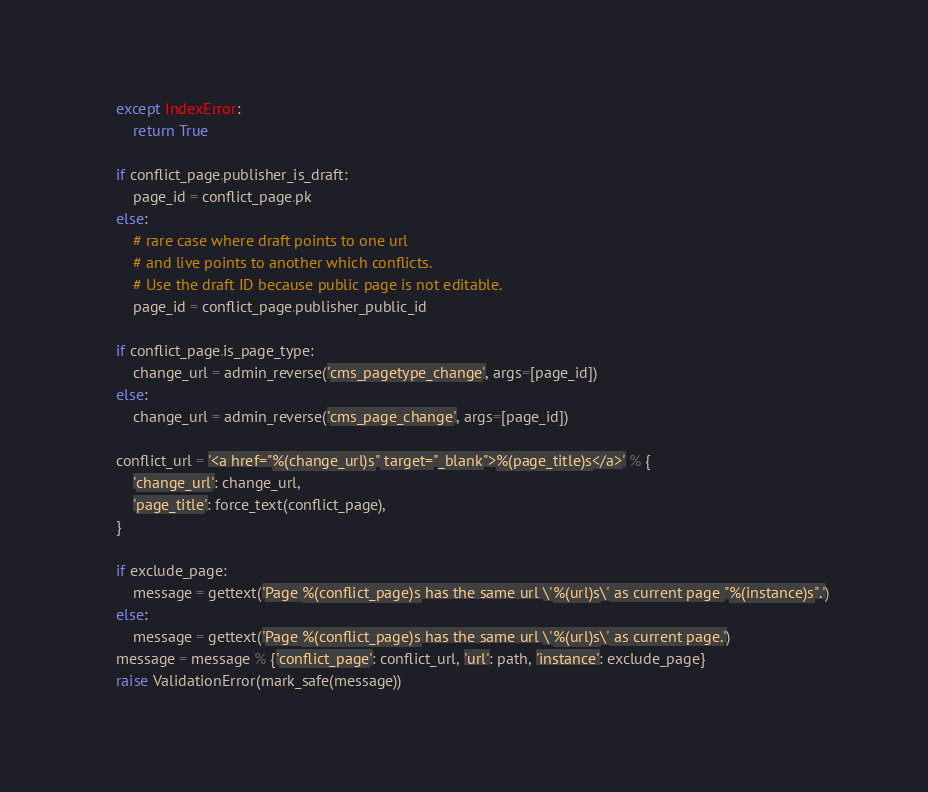<code> <loc_0><loc_0><loc_500><loc_500><_Python_>    except IndexError:
        return True

    if conflict_page.publisher_is_draft:
        page_id = conflict_page.pk
    else:
        # rare case where draft points to one url
        # and live points to another which conflicts.
        # Use the draft ID because public page is not editable.
        page_id = conflict_page.publisher_public_id

    if conflict_page.is_page_type:
        change_url = admin_reverse('cms_pagetype_change', args=[page_id])
    else:
        change_url = admin_reverse('cms_page_change', args=[page_id])

    conflict_url = '<a href="%(change_url)s" target="_blank">%(page_title)s</a>' % {
        'change_url': change_url,
        'page_title': force_text(conflict_page),
    }

    if exclude_page:
        message = gettext('Page %(conflict_page)s has the same url \'%(url)s\' as current page "%(instance)s".')
    else:
        message = gettext('Page %(conflict_page)s has the same url \'%(url)s\' as current page.')
    message = message % {'conflict_page': conflict_url, 'url': path, 'instance': exclude_page}
    raise ValidationError(mark_safe(message))
</code> 